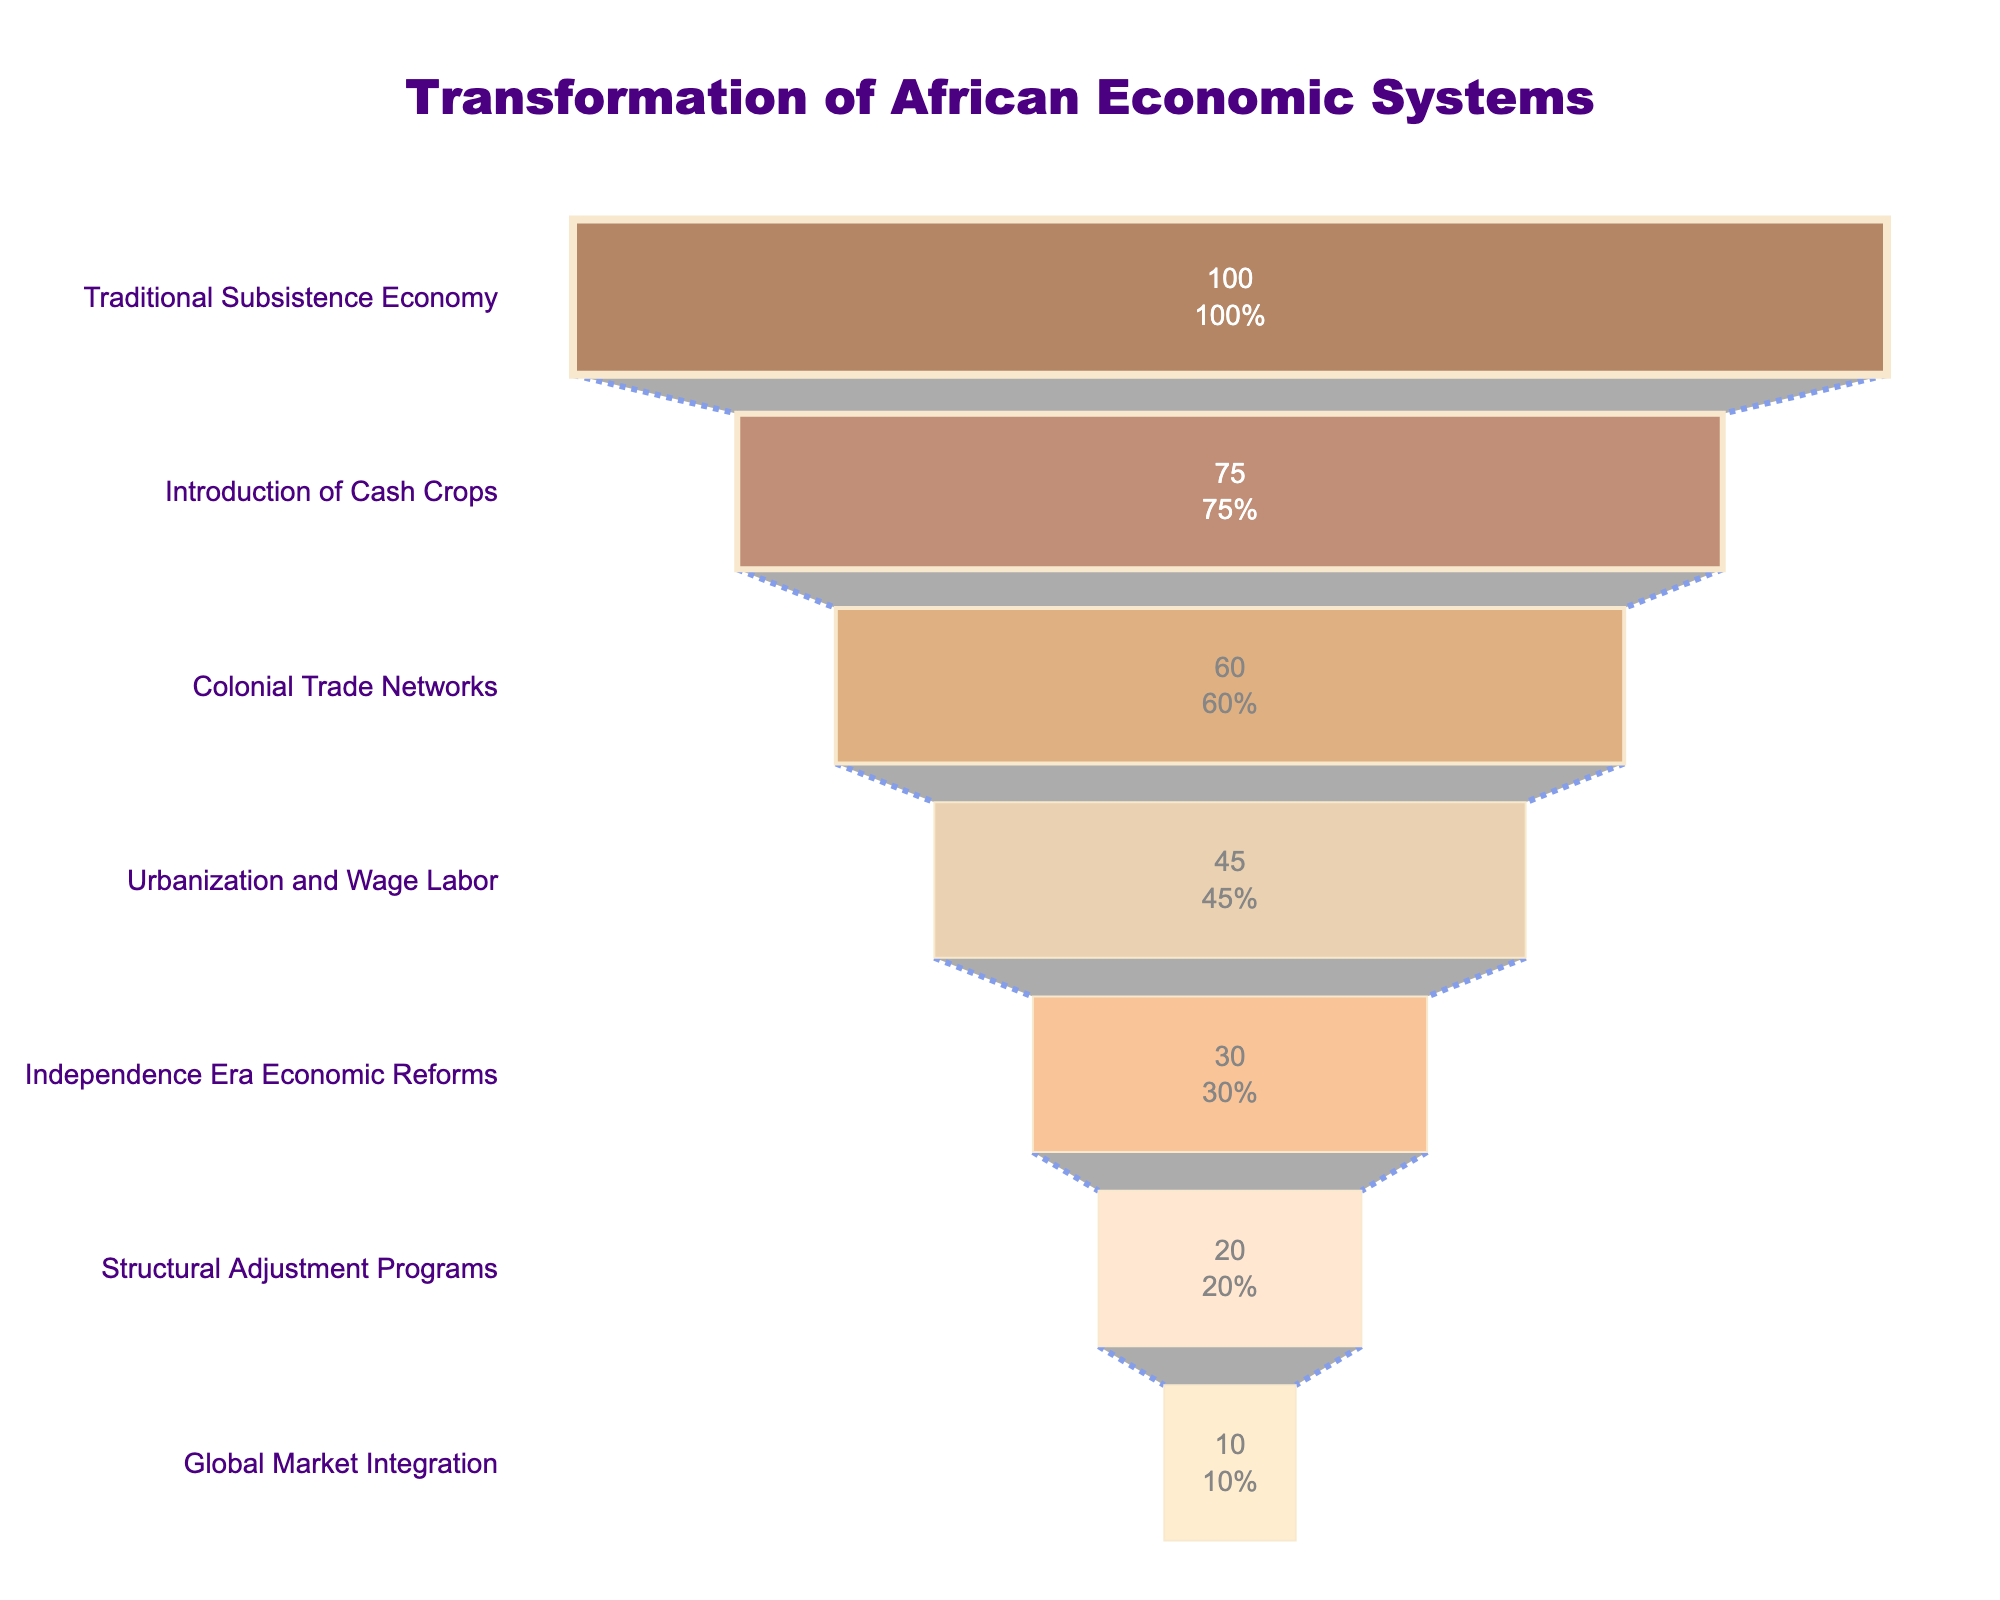What is the title of the funnel chart? The title of the chart is usually found at the top center of the figure. It provides a summary of the overall theme of the visualized data. In this case, the title is "Transformation of African Economic Systems".
Answer: Transformation of African Economic Systems Which stage indicates the highest percentage? The highest percentage is the largest value on the horizontal axis and it usually corresponds to the first stage in a funnel chart. Here, the stage with 100% is "Traditional Subsistence Economy".
Answer: Traditional Subsistence Economy How does the percentage change from the "Introduction of Cash Crops" to "Colonial Trade Networks"? To find the change, subtract the percentage of the "Colonial Trade Networks" (60%) from the percentage of the "Introduction of Cash Crops" (75%). 75% - 60% = 15%.
Answer: 15% Which stage shows the smallest percentage? The smallest percentage can be identified at the end of the funnel, which in this case is "Global Market Integration" with 10%.
Answer: Global Market Integration How many stages are depicted in the funnel chart? Count the number of different stages listed along the vertical axis to find the total stages in the funnel chart. Here, there are seven stages.
Answer: 7 What percentage represents "Independence Era Economic Reforms"? Look for the label "Independence Era Economic Reforms" on the vertical axis and read its corresponding value on the horizontal axis. It is 30%.
Answer: 30% What is the total decline in percentage points from "Traditional Subsistence Economy" to "Global Market Integration"? Calculate the difference between the initial value (100%) and the final value (10%). 100% - 10% = 90%.
Answer: 90% Compare the percentage of "Urbanization and Wage Labor" to "Structural Adjustment Programs". Which stage has a higher percentage? Observe the two stages and their corresponding percentages. "Urbanization and Wage Labor" has 45%, while "Structural Adjustment Programs" has 20%. Therefore, "Urbanization and Wage Labor" is higher.
Answer: Urbanization and Wage Labor What is the average percentage of all the stages? Sum up all the percentages (100% + 75% + 60% + 45% + 30% + 20% + 10%) and then divide by the number of stages (7). The total is 340%, so the average is 340/7 ≈ 48.57%.
Answer: 48.57% How does the percentage drop between "Colonial Trade Networks" and "Independence Era Economic Reforms"? Subtract the percentage of "Independence Era Economic Reforms" (30%) from "Colonial Trade Networks" (60%). 60% - 30% = 30%.
Answer: 30% 